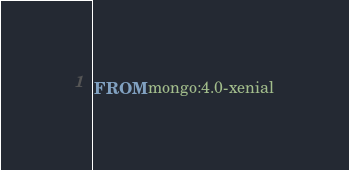Convert code to text. <code><loc_0><loc_0><loc_500><loc_500><_Dockerfile_>FROM mongo:4.0-xenial
</code> 